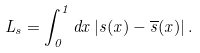Convert formula to latex. <formula><loc_0><loc_0><loc_500><loc_500>L _ { s } = \int _ { 0 } ^ { 1 } d x \, | s ( x ) - \overline { s } ( x ) | \, .</formula> 